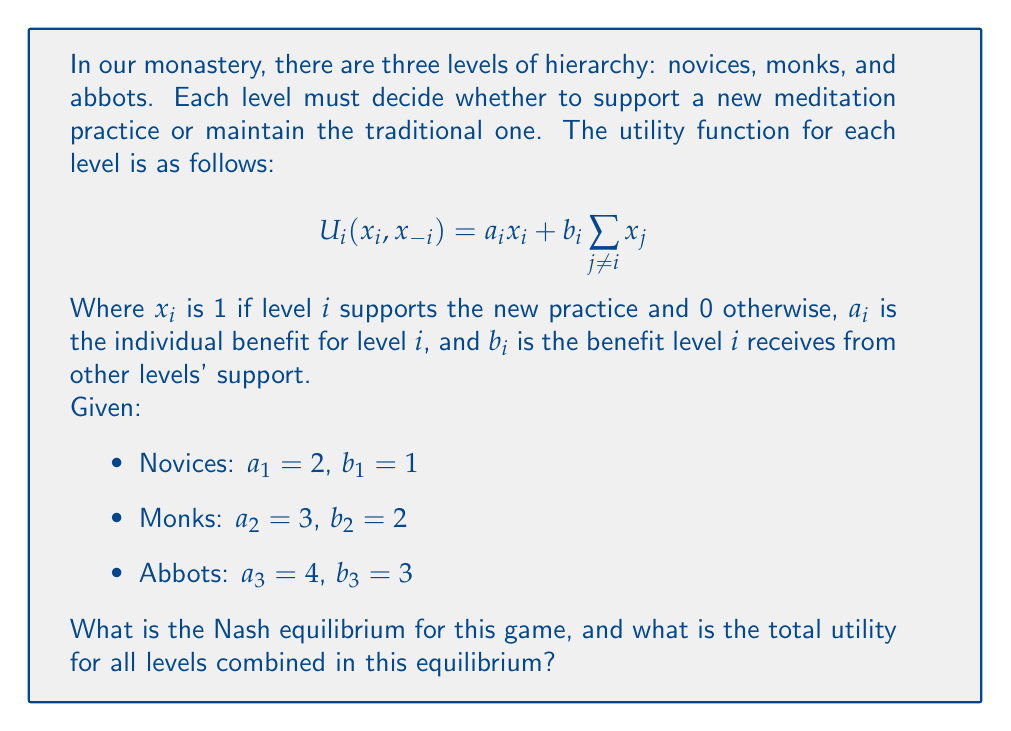Can you solve this math problem? To solve this game theory problem, we need to analyze the best response of each level given the decisions of the others.

1) First, let's consider the decision for each level:

   For any level $i$, they will support the new practice if:
   $$a_i + b_i\sum_{j \neq i} x_j > b_i\sum_{j \neq i} x_j$$
   Which simplifies to: $a_i > 0$

2) Since $a_i > 0$ for all levels, each level's dominant strategy is to support the new practice regardless of what others do.

3) Therefore, the Nash equilibrium is $(1, 1, 1)$, where all levels support the new practice.

4) Now, let's calculate the utility for each level in this equilibrium:

   Novices: $U_1 = 2(1) + 1(1+1) = 4$
   Monks: $U_2 = 3(1) + 2(1+1) = 7$
   Abbots: $U_3 = 4(1) + 3(1+1) = 10$

5) The total utility is the sum of all levels' utilities:
   $U_{total} = 4 + 7 + 10 = 21$

Thus, the Nash equilibrium is for all levels to support the new practice, resulting in a total utility of 21.
Answer: The Nash equilibrium is $(1, 1, 1)$, and the total utility in this equilibrium is 21. 